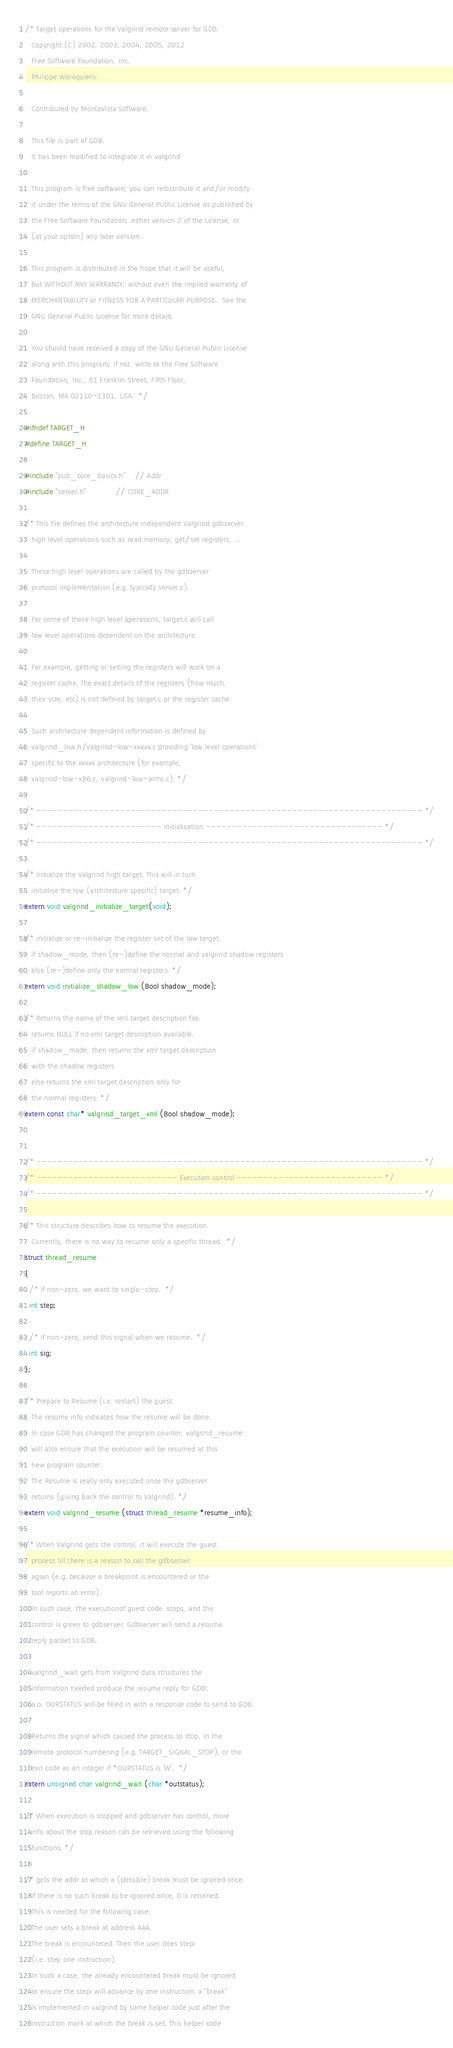Convert code to text. <code><loc_0><loc_0><loc_500><loc_500><_C_>/* Target operations for the Valgrind remote server for GDB.
   Copyright (C) 2002, 2003, 2004, 2005, 2012
   Free Software Foundation, Inc.
   Philippe Waroquiers.

   Contributed by MontaVista Software.

   This file is part of GDB.
   It has been modified to integrate it in valgrind

   This program is free software; you can redistribute it and/or modify
   it under the terms of the GNU General Public License as published by
   the Free Software Foundation; either version 2 of the License, or
   (at your option) any later version.

   This program is distributed in the hope that it will be useful,
   but WITHOUT ANY WARRANTY; without even the implied warranty of
   MERCHANTABILITY or FITNESS FOR A PARTICULAR PURPOSE.  See the
   GNU General Public License for more details.

   You should have received a copy of the GNU General Public License
   along with this program; if not, write to the Free Software
   Foundation, Inc., 51 Franklin Street, Fifth Floor,
   Boston, MA 02110-1301, USA.  */

#ifndef TARGET_H
#define TARGET_H

#include "pub_core_basics.h"    // Addr
#include "server.h"             // CORE_ADDR

/* This file defines the architecture independent Valgrind gdbserver
   high level operations such as read memory, get/set registers, ...

   These high level operations are called by the gdbserver
   protocol implementation (e.g. typically server.c).
   
   For some of these high level operations, target.c will call
   low level operations dependent on the architecture.
   
   For example, getting or setting the registers will work on a
   register cache. The exact details of the registers (how much,
   their size, etc) is not defined by target.c or the register cache.

   Such architecture dependent information is defined by
   valgrind_low.h/valgrind-low-xxxxx.c providing 'low level operations'
   specific to the xxxxx architecture (for example,
   valgrind-low-x86.c, valgrind-low-armc.c). */
        
/* -------------------------------------------------------------------------- */
/* ------------------------ Initialisation ---------------------------------- */
/* -------------------------------------------------------------------------- */

/* Initialize the Valgrind high target. This will in turn
   initialise the low (architecture specific) target. */
extern void valgrind_initialize_target(void);

/* initialize or re-initialize the register set of the low target.
   if shadow_mode, then (re-)define the normal and valgrind shadow registers
   else (re-)define only the normal registers. */
extern void initialize_shadow_low (Bool shadow_mode);

/* Returns the name of the xml target description file. 
   returns NULL if no xml target description available.
   if shadow_mode, then returns the xml target description
   with the shadow registers
   else returns the xml target description only for
   the normal registers. */
extern const char* valgrind_target_xml (Bool shadow_mode);


/* -------------------------------------------------------------------------- */
/* --------------------------- Execution control ---------------------------- */
/* -------------------------------------------------------------------------- */

/* This structure describes how to resume the execution.
   Currently, there is no way to resume only a specific thread.  */
struct thread_resume
{
  /* If non-zero, we want to single-step.  */
  int step;

  /* If non-zero, send this signal when we resume.  */
  int sig;
};

/* Prepare to Resume (i.e. restart) the guest.
   The resume info indicates how the resume will be done. 
   In case GDB has changed the program counter, valgrind_resume
   will also ensure that the execution will be resumed at this
   new program counter.
   The Resume is really only executed once the gdbserver
   returns (giving back the control to Valgrind). */
extern void valgrind_resume (struct thread_resume *resume_info);

/* When Valgrind gets the control, it will execute the guest
   process till there is a reason to call the gdbserver
   again (e.g. because a breakpoint is encountered or the
   tool reports an error).
   In such case, the executionof guest code  stops, and the
   control is given to gdbserver. Gdbserver will send a resume
   reply packet to GDB.

   valgrind_wait gets from Valgrind data structures the
   information needed produce the resume reply for GDB:
   a.o. OURSTATUS will be filled in with a response code to send to GDB.

   Returns the signal which caused the process to stop, in the
   remote protocol numbering (e.g. TARGET_SIGNAL_STOP), or the
   exit code as an integer if *OURSTATUS is 'W'.  */
extern unsigned char valgrind_wait (char *outstatus);

/* When execution is stopped and gdbserver has control, more
   info about the stop reason can be retrieved using the following
   functions. */

/* gets the addr at which a (possible) break must be ignored once.
   If there is no such break to be ignored once, 0 is returned.
   This is needed for the following case:
   The user sets a break at address AAA.
   The break is encountered. Then the user does stepi 
   (i.e. step one instruction).
   In such a case, the already encountered break must be ignored
   to ensure the stepi will advance by one instruction: a "break"
   is implemented in valgrind by some helper code just after the
   instruction mark at which the break is set. This helper code</code> 